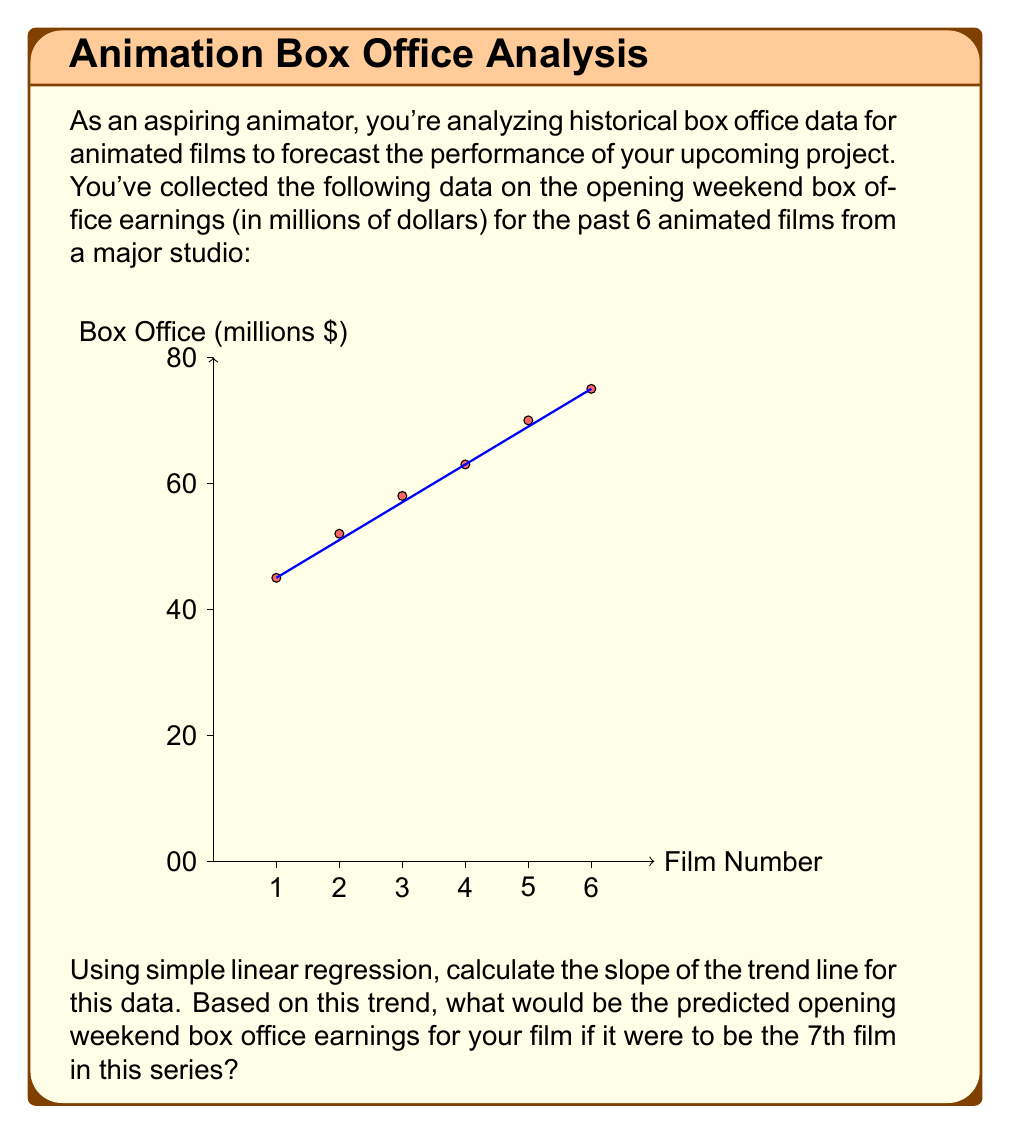Can you solve this math problem? To solve this problem, we'll use the simple linear regression formula:

$$m = \frac{n\sum xy - \sum x \sum y}{n\sum x^2 - (\sum x)^2}$$

Where:
$m$ is the slope
$n$ is the number of data points
$x$ are the film numbers
$y$ are the box office earnings

Step 1: Calculate the necessary sums:
$n = 6$
$\sum x = 1 + 2 + 3 + 4 + 5 + 6 = 21$
$\sum y = 45 + 52 + 58 + 63 + 70 + 75 = 363$
$\sum xy = 1(45) + 2(52) + 3(58) + 4(63) + 5(70) + 6(75) = 1,426$
$\sum x^2 = 1^2 + 2^2 + 3^2 + 4^2 + 5^2 + 6^2 = 91$

Step 2: Plug these values into the slope formula:

$$m = \frac{6(1,426) - 21(363)}{6(91) - 21^2} = \frac{8,556 - 7,623}{546 - 441} = \frac{933}{105} = 6.2$$

Step 3: Now that we have the slope, we can use the point-slope form of a line to predict the 7th film's earnings:

$$y - y_1 = m(x - x_1)$$

We'll use the last data point (6, 75) as our known point:

$$y - 75 = 6.2(7 - 6)$$

Step 4: Solve for y:

$$y - 75 = 6.2$$
$$y = 81.2$$

Therefore, the predicted opening weekend box office earnings for the 7th film would be $81.2 million.
Answer: $81.2 million 